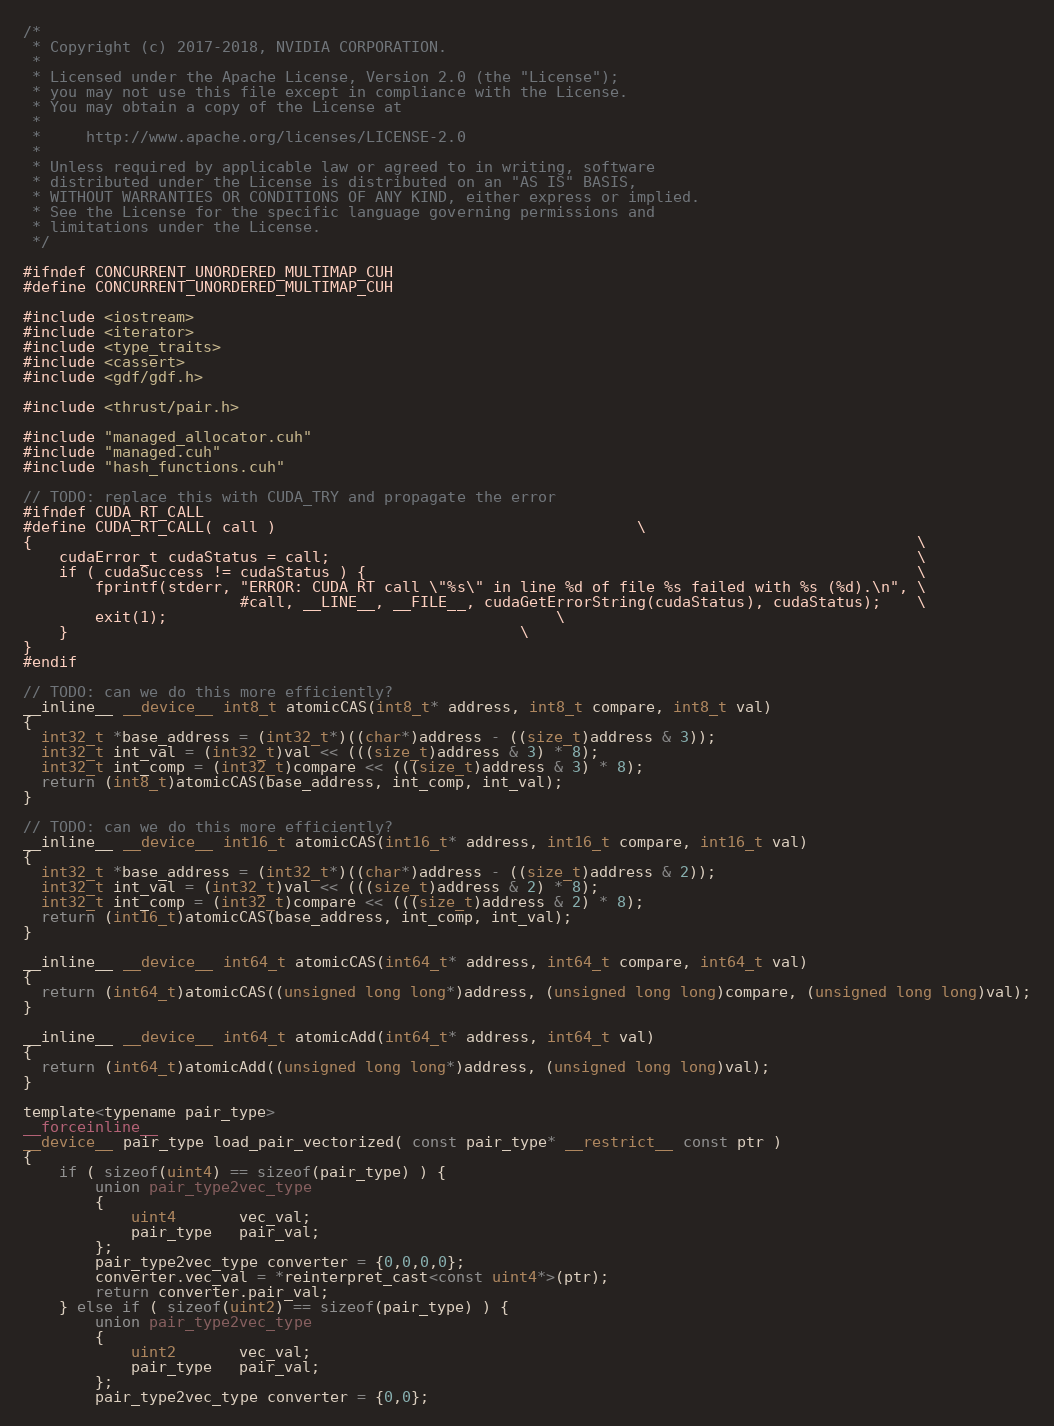Convert code to text. <code><loc_0><loc_0><loc_500><loc_500><_Cuda_>/*
 * Copyright (c) 2017-2018, NVIDIA CORPORATION.
 *
 * Licensed under the Apache License, Version 2.0 (the "License");
 * you may not use this file except in compliance with the License.
 * You may obtain a copy of the License at
 *
 *     http://www.apache.org/licenses/LICENSE-2.0
 *
 * Unless required by applicable law or agreed to in writing, software
 * distributed under the License is distributed on an "AS IS" BASIS,
 * WITHOUT WARRANTIES OR CONDITIONS OF ANY KIND, either express or implied.
 * See the License for the specific language governing permissions and
 * limitations under the License.
 */

#ifndef CONCURRENT_UNORDERED_MULTIMAP_CUH
#define CONCURRENT_UNORDERED_MULTIMAP_CUH

#include <iostream>
#include <iterator>
#include <type_traits>
#include <cassert>
#include <gdf/gdf.h>

#include <thrust/pair.h>

#include "managed_allocator.cuh"
#include "managed.cuh"
#include "hash_functions.cuh"

// TODO: replace this with CUDA_TRY and propagate the error
#ifndef CUDA_RT_CALL
#define CUDA_RT_CALL( call ) 									   \
{                                                                                                  \
    cudaError_t cudaStatus = call;                                                                 \
    if ( cudaSuccess != cudaStatus ) {                                                             \
        fprintf(stderr, "ERROR: CUDA RT call \"%s\" in line %d of file %s failed with %s (%d).\n", \
                        #call, __LINE__, __FILE__, cudaGetErrorString(cudaStatus), cudaStatus);    \
        exit(1);										   \
    }												   \
}
#endif

// TODO: can we do this more efficiently?
__inline__ __device__ int8_t atomicCAS(int8_t* address, int8_t compare, int8_t val)
{
  int32_t *base_address = (int32_t*)((char*)address - ((size_t)address & 3));
  int32_t int_val = (int32_t)val << (((size_t)address & 3) * 8);
  int32_t int_comp = (int32_t)compare << (((size_t)address & 3) * 8);
  return (int8_t)atomicCAS(base_address, int_comp, int_val);
}

// TODO: can we do this more efficiently?
__inline__ __device__ int16_t atomicCAS(int16_t* address, int16_t compare, int16_t val)
{
  int32_t *base_address = (int32_t*)((char*)address - ((size_t)address & 2));
  int32_t int_val = (int32_t)val << (((size_t)address & 2) * 8);
  int32_t int_comp = (int32_t)compare << (((size_t)address & 2) * 8);
  return (int16_t)atomicCAS(base_address, int_comp, int_val);
}

__inline__ __device__ int64_t atomicCAS(int64_t* address, int64_t compare, int64_t val)
{
  return (int64_t)atomicCAS((unsigned long long*)address, (unsigned long long)compare, (unsigned long long)val);
}

__inline__ __device__ int64_t atomicAdd(int64_t* address, int64_t val)
{
  return (int64_t)atomicAdd((unsigned long long*)address, (unsigned long long)val);
}

template<typename pair_type>
__forceinline__
__device__ pair_type load_pair_vectorized( const pair_type* __restrict__ const ptr )
{
    if ( sizeof(uint4) == sizeof(pair_type) ) {
        union pair_type2vec_type
        {
            uint4       vec_val;
            pair_type   pair_val;
        };
        pair_type2vec_type converter = {0,0,0,0};
        converter.vec_val = *reinterpret_cast<const uint4*>(ptr);
        return converter.pair_val;
    } else if ( sizeof(uint2) == sizeof(pair_type) ) {
        union pair_type2vec_type
        {
            uint2       vec_val;
            pair_type   pair_val;
        };
        pair_type2vec_type converter = {0,0};</code> 